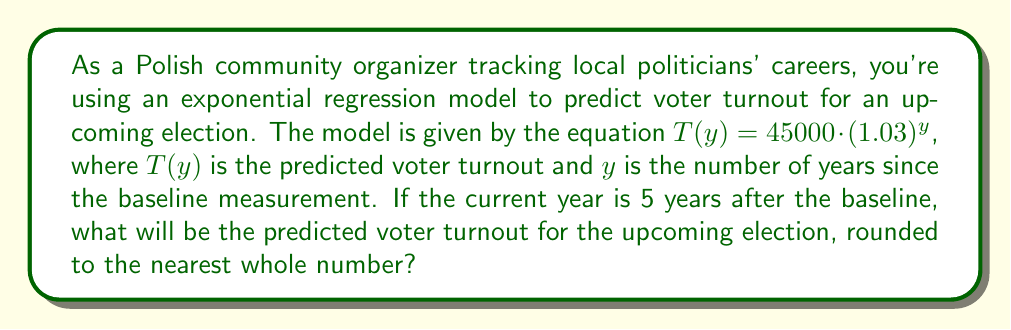What is the answer to this math problem? To solve this problem, we need to use the given exponential regression model and substitute the appropriate value for $y$. Let's break it down step-by-step:

1. The model is given by: $T(y) = 45000 \cdot (1.03)^y$

2. We're told that the current year is 5 years after the baseline, so $y = 5$

3. Let's substitute $y = 5$ into the equation:
   $T(5) = 45000 \cdot (1.03)^5$

4. Now, let's calculate this:
   $T(5) = 45000 \cdot 1.159274$
   
5. Multiply:
   $T(5) = 52167.33$

6. Round to the nearest whole number:
   $T(5) \approx 52167$

This exponential model suggests that voter turnout is increasing by 3% each year from the baseline measurement of 45,000 voters.
Answer: 52167 voters 